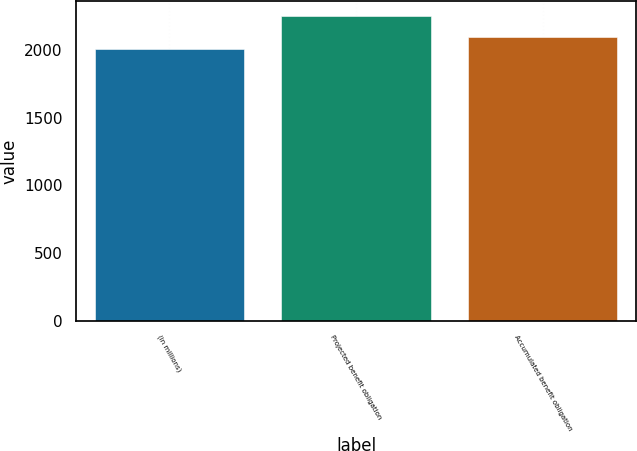Convert chart. <chart><loc_0><loc_0><loc_500><loc_500><bar_chart><fcel>(in millions)<fcel>Projected benefit obligation<fcel>Accumulated benefit obligation<nl><fcel>2009<fcel>2249<fcel>2099<nl></chart> 